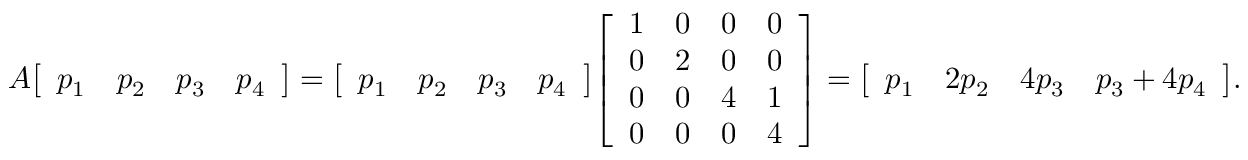<formula> <loc_0><loc_0><loc_500><loc_500>A { \left [ \begin{array} { l l l l } { p _ { 1 } } & { p _ { 2 } } & { p _ { 3 } } & { p _ { 4 } } \end{array} \right ] } = { \left [ \begin{array} { l l l l } { p _ { 1 } } & { p _ { 2 } } & { p _ { 3 } } & { p _ { 4 } } \end{array} \right ] } { \left [ \begin{array} { l l l l } { 1 } & { 0 } & { 0 } & { 0 } \\ { 0 } & { 2 } & { 0 } & { 0 } \\ { 0 } & { 0 } & { 4 } & { 1 } \\ { 0 } & { 0 } & { 0 } & { 4 } \end{array} \right ] } = { \left [ \begin{array} { l l l l } { p _ { 1 } } & { 2 p _ { 2 } } & { 4 p _ { 3 } } & { p _ { 3 } + 4 p _ { 4 } } \end{array} \right ] } .</formula> 